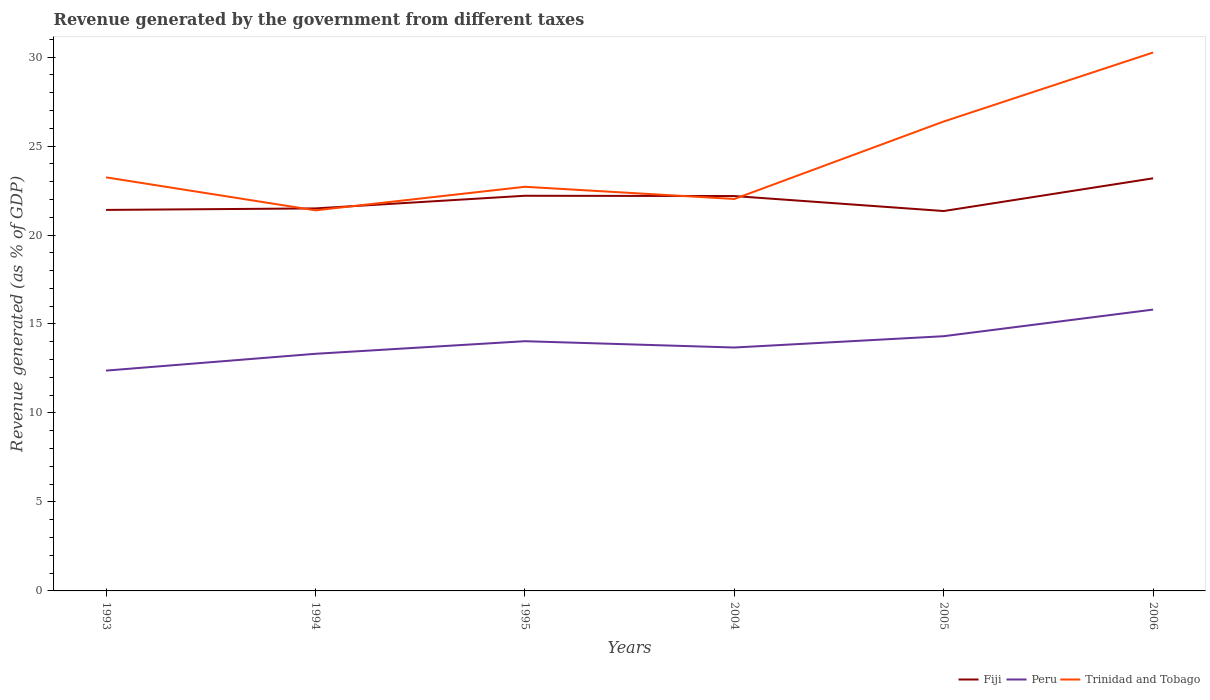Is the number of lines equal to the number of legend labels?
Your answer should be compact. Yes. Across all years, what is the maximum revenue generated by the government in Peru?
Ensure brevity in your answer.  12.38. In which year was the revenue generated by the government in Fiji maximum?
Offer a very short reply. 2005. What is the total revenue generated by the government in Trinidad and Tobago in the graph?
Your answer should be very brief. 0.69. What is the difference between the highest and the second highest revenue generated by the government in Peru?
Your answer should be compact. 3.43. What is the difference between the highest and the lowest revenue generated by the government in Peru?
Make the answer very short. 3. Is the revenue generated by the government in Peru strictly greater than the revenue generated by the government in Trinidad and Tobago over the years?
Your answer should be compact. Yes. How many lines are there?
Ensure brevity in your answer.  3. What is the difference between two consecutive major ticks on the Y-axis?
Make the answer very short. 5. Are the values on the major ticks of Y-axis written in scientific E-notation?
Your response must be concise. No. Does the graph contain grids?
Keep it short and to the point. No. How many legend labels are there?
Offer a very short reply. 3. What is the title of the graph?
Make the answer very short. Revenue generated by the government from different taxes. Does "Middle East & North Africa (developing only)" appear as one of the legend labels in the graph?
Make the answer very short. No. What is the label or title of the X-axis?
Keep it short and to the point. Years. What is the label or title of the Y-axis?
Offer a terse response. Revenue generated (as % of GDP). What is the Revenue generated (as % of GDP) in Fiji in 1993?
Give a very brief answer. 21.41. What is the Revenue generated (as % of GDP) in Peru in 1993?
Offer a terse response. 12.38. What is the Revenue generated (as % of GDP) in Trinidad and Tobago in 1993?
Keep it short and to the point. 23.24. What is the Revenue generated (as % of GDP) in Fiji in 1994?
Keep it short and to the point. 21.5. What is the Revenue generated (as % of GDP) in Peru in 1994?
Your answer should be compact. 13.33. What is the Revenue generated (as % of GDP) in Trinidad and Tobago in 1994?
Make the answer very short. 21.39. What is the Revenue generated (as % of GDP) of Fiji in 1995?
Your answer should be compact. 22.21. What is the Revenue generated (as % of GDP) in Peru in 1995?
Provide a short and direct response. 14.03. What is the Revenue generated (as % of GDP) in Trinidad and Tobago in 1995?
Provide a succinct answer. 22.71. What is the Revenue generated (as % of GDP) in Fiji in 2004?
Your response must be concise. 22.19. What is the Revenue generated (as % of GDP) in Peru in 2004?
Make the answer very short. 13.68. What is the Revenue generated (as % of GDP) in Trinidad and Tobago in 2004?
Make the answer very short. 22.03. What is the Revenue generated (as % of GDP) in Fiji in 2005?
Your answer should be very brief. 21.35. What is the Revenue generated (as % of GDP) in Peru in 2005?
Give a very brief answer. 14.31. What is the Revenue generated (as % of GDP) in Trinidad and Tobago in 2005?
Give a very brief answer. 26.38. What is the Revenue generated (as % of GDP) in Fiji in 2006?
Ensure brevity in your answer.  23.19. What is the Revenue generated (as % of GDP) of Peru in 2006?
Keep it short and to the point. 15.81. What is the Revenue generated (as % of GDP) of Trinidad and Tobago in 2006?
Offer a terse response. 30.26. Across all years, what is the maximum Revenue generated (as % of GDP) of Fiji?
Your answer should be compact. 23.19. Across all years, what is the maximum Revenue generated (as % of GDP) in Peru?
Ensure brevity in your answer.  15.81. Across all years, what is the maximum Revenue generated (as % of GDP) of Trinidad and Tobago?
Your answer should be very brief. 30.26. Across all years, what is the minimum Revenue generated (as % of GDP) of Fiji?
Offer a very short reply. 21.35. Across all years, what is the minimum Revenue generated (as % of GDP) of Peru?
Offer a very short reply. 12.38. Across all years, what is the minimum Revenue generated (as % of GDP) of Trinidad and Tobago?
Your answer should be very brief. 21.39. What is the total Revenue generated (as % of GDP) of Fiji in the graph?
Your answer should be very brief. 131.84. What is the total Revenue generated (as % of GDP) of Peru in the graph?
Your answer should be compact. 83.54. What is the total Revenue generated (as % of GDP) in Trinidad and Tobago in the graph?
Your answer should be very brief. 146. What is the difference between the Revenue generated (as % of GDP) of Fiji in 1993 and that in 1994?
Give a very brief answer. -0.09. What is the difference between the Revenue generated (as % of GDP) in Peru in 1993 and that in 1994?
Provide a short and direct response. -0.94. What is the difference between the Revenue generated (as % of GDP) in Trinidad and Tobago in 1993 and that in 1994?
Offer a terse response. 1.85. What is the difference between the Revenue generated (as % of GDP) in Fiji in 1993 and that in 1995?
Ensure brevity in your answer.  -0.8. What is the difference between the Revenue generated (as % of GDP) in Peru in 1993 and that in 1995?
Your response must be concise. -1.65. What is the difference between the Revenue generated (as % of GDP) of Trinidad and Tobago in 1993 and that in 1995?
Your answer should be compact. 0.53. What is the difference between the Revenue generated (as % of GDP) in Fiji in 1993 and that in 2004?
Keep it short and to the point. -0.78. What is the difference between the Revenue generated (as % of GDP) in Peru in 1993 and that in 2004?
Make the answer very short. -1.3. What is the difference between the Revenue generated (as % of GDP) of Trinidad and Tobago in 1993 and that in 2004?
Your answer should be compact. 1.21. What is the difference between the Revenue generated (as % of GDP) of Fiji in 1993 and that in 2005?
Your answer should be compact. 0.06. What is the difference between the Revenue generated (as % of GDP) of Peru in 1993 and that in 2005?
Keep it short and to the point. -1.93. What is the difference between the Revenue generated (as % of GDP) of Trinidad and Tobago in 1993 and that in 2005?
Give a very brief answer. -3.14. What is the difference between the Revenue generated (as % of GDP) in Fiji in 1993 and that in 2006?
Ensure brevity in your answer.  -1.78. What is the difference between the Revenue generated (as % of GDP) in Peru in 1993 and that in 2006?
Your response must be concise. -3.43. What is the difference between the Revenue generated (as % of GDP) in Trinidad and Tobago in 1993 and that in 2006?
Make the answer very short. -7.02. What is the difference between the Revenue generated (as % of GDP) in Fiji in 1994 and that in 1995?
Offer a very short reply. -0.71. What is the difference between the Revenue generated (as % of GDP) in Peru in 1994 and that in 1995?
Offer a terse response. -0.71. What is the difference between the Revenue generated (as % of GDP) in Trinidad and Tobago in 1994 and that in 1995?
Offer a very short reply. -1.32. What is the difference between the Revenue generated (as % of GDP) of Fiji in 1994 and that in 2004?
Make the answer very short. -0.69. What is the difference between the Revenue generated (as % of GDP) in Peru in 1994 and that in 2004?
Ensure brevity in your answer.  -0.35. What is the difference between the Revenue generated (as % of GDP) of Trinidad and Tobago in 1994 and that in 2004?
Give a very brief answer. -0.64. What is the difference between the Revenue generated (as % of GDP) in Fiji in 1994 and that in 2005?
Your answer should be very brief. 0.15. What is the difference between the Revenue generated (as % of GDP) in Peru in 1994 and that in 2005?
Ensure brevity in your answer.  -0.99. What is the difference between the Revenue generated (as % of GDP) in Trinidad and Tobago in 1994 and that in 2005?
Your answer should be compact. -4.99. What is the difference between the Revenue generated (as % of GDP) in Fiji in 1994 and that in 2006?
Provide a succinct answer. -1.69. What is the difference between the Revenue generated (as % of GDP) of Peru in 1994 and that in 2006?
Ensure brevity in your answer.  -2.48. What is the difference between the Revenue generated (as % of GDP) in Trinidad and Tobago in 1994 and that in 2006?
Provide a succinct answer. -8.87. What is the difference between the Revenue generated (as % of GDP) of Fiji in 1995 and that in 2004?
Your answer should be compact. 0.02. What is the difference between the Revenue generated (as % of GDP) of Peru in 1995 and that in 2004?
Provide a short and direct response. 0.35. What is the difference between the Revenue generated (as % of GDP) of Trinidad and Tobago in 1995 and that in 2004?
Provide a succinct answer. 0.69. What is the difference between the Revenue generated (as % of GDP) of Fiji in 1995 and that in 2005?
Keep it short and to the point. 0.86. What is the difference between the Revenue generated (as % of GDP) of Peru in 1995 and that in 2005?
Your answer should be compact. -0.28. What is the difference between the Revenue generated (as % of GDP) in Trinidad and Tobago in 1995 and that in 2005?
Keep it short and to the point. -3.67. What is the difference between the Revenue generated (as % of GDP) of Fiji in 1995 and that in 2006?
Make the answer very short. -0.98. What is the difference between the Revenue generated (as % of GDP) in Peru in 1995 and that in 2006?
Your answer should be compact. -1.78. What is the difference between the Revenue generated (as % of GDP) in Trinidad and Tobago in 1995 and that in 2006?
Provide a succinct answer. -7.55. What is the difference between the Revenue generated (as % of GDP) in Fiji in 2004 and that in 2005?
Make the answer very short. 0.84. What is the difference between the Revenue generated (as % of GDP) of Peru in 2004 and that in 2005?
Your response must be concise. -0.64. What is the difference between the Revenue generated (as % of GDP) of Trinidad and Tobago in 2004 and that in 2005?
Your answer should be very brief. -4.35. What is the difference between the Revenue generated (as % of GDP) in Fiji in 2004 and that in 2006?
Offer a very short reply. -1. What is the difference between the Revenue generated (as % of GDP) of Peru in 2004 and that in 2006?
Your answer should be very brief. -2.13. What is the difference between the Revenue generated (as % of GDP) of Trinidad and Tobago in 2004 and that in 2006?
Give a very brief answer. -8.23. What is the difference between the Revenue generated (as % of GDP) in Fiji in 2005 and that in 2006?
Your response must be concise. -1.84. What is the difference between the Revenue generated (as % of GDP) in Peru in 2005 and that in 2006?
Keep it short and to the point. -1.5. What is the difference between the Revenue generated (as % of GDP) of Trinidad and Tobago in 2005 and that in 2006?
Offer a terse response. -3.88. What is the difference between the Revenue generated (as % of GDP) of Fiji in 1993 and the Revenue generated (as % of GDP) of Peru in 1994?
Your answer should be very brief. 8.09. What is the difference between the Revenue generated (as % of GDP) in Fiji in 1993 and the Revenue generated (as % of GDP) in Trinidad and Tobago in 1994?
Make the answer very short. 0.02. What is the difference between the Revenue generated (as % of GDP) of Peru in 1993 and the Revenue generated (as % of GDP) of Trinidad and Tobago in 1994?
Keep it short and to the point. -9.01. What is the difference between the Revenue generated (as % of GDP) in Fiji in 1993 and the Revenue generated (as % of GDP) in Peru in 1995?
Provide a short and direct response. 7.38. What is the difference between the Revenue generated (as % of GDP) of Fiji in 1993 and the Revenue generated (as % of GDP) of Trinidad and Tobago in 1995?
Ensure brevity in your answer.  -1.3. What is the difference between the Revenue generated (as % of GDP) of Peru in 1993 and the Revenue generated (as % of GDP) of Trinidad and Tobago in 1995?
Make the answer very short. -10.33. What is the difference between the Revenue generated (as % of GDP) of Fiji in 1993 and the Revenue generated (as % of GDP) of Peru in 2004?
Keep it short and to the point. 7.73. What is the difference between the Revenue generated (as % of GDP) in Fiji in 1993 and the Revenue generated (as % of GDP) in Trinidad and Tobago in 2004?
Ensure brevity in your answer.  -0.61. What is the difference between the Revenue generated (as % of GDP) in Peru in 1993 and the Revenue generated (as % of GDP) in Trinidad and Tobago in 2004?
Your response must be concise. -9.64. What is the difference between the Revenue generated (as % of GDP) in Fiji in 1993 and the Revenue generated (as % of GDP) in Peru in 2005?
Keep it short and to the point. 7.1. What is the difference between the Revenue generated (as % of GDP) in Fiji in 1993 and the Revenue generated (as % of GDP) in Trinidad and Tobago in 2005?
Ensure brevity in your answer.  -4.97. What is the difference between the Revenue generated (as % of GDP) in Peru in 1993 and the Revenue generated (as % of GDP) in Trinidad and Tobago in 2005?
Provide a short and direct response. -14. What is the difference between the Revenue generated (as % of GDP) of Fiji in 1993 and the Revenue generated (as % of GDP) of Peru in 2006?
Offer a very short reply. 5.6. What is the difference between the Revenue generated (as % of GDP) in Fiji in 1993 and the Revenue generated (as % of GDP) in Trinidad and Tobago in 2006?
Your response must be concise. -8.85. What is the difference between the Revenue generated (as % of GDP) in Peru in 1993 and the Revenue generated (as % of GDP) in Trinidad and Tobago in 2006?
Offer a terse response. -17.88. What is the difference between the Revenue generated (as % of GDP) of Fiji in 1994 and the Revenue generated (as % of GDP) of Peru in 1995?
Your answer should be compact. 7.46. What is the difference between the Revenue generated (as % of GDP) of Fiji in 1994 and the Revenue generated (as % of GDP) of Trinidad and Tobago in 1995?
Ensure brevity in your answer.  -1.22. What is the difference between the Revenue generated (as % of GDP) of Peru in 1994 and the Revenue generated (as % of GDP) of Trinidad and Tobago in 1995?
Your answer should be very brief. -9.39. What is the difference between the Revenue generated (as % of GDP) of Fiji in 1994 and the Revenue generated (as % of GDP) of Peru in 2004?
Your response must be concise. 7.82. What is the difference between the Revenue generated (as % of GDP) of Fiji in 1994 and the Revenue generated (as % of GDP) of Trinidad and Tobago in 2004?
Give a very brief answer. -0.53. What is the difference between the Revenue generated (as % of GDP) of Peru in 1994 and the Revenue generated (as % of GDP) of Trinidad and Tobago in 2004?
Your answer should be very brief. -8.7. What is the difference between the Revenue generated (as % of GDP) of Fiji in 1994 and the Revenue generated (as % of GDP) of Peru in 2005?
Give a very brief answer. 7.18. What is the difference between the Revenue generated (as % of GDP) in Fiji in 1994 and the Revenue generated (as % of GDP) in Trinidad and Tobago in 2005?
Ensure brevity in your answer.  -4.88. What is the difference between the Revenue generated (as % of GDP) in Peru in 1994 and the Revenue generated (as % of GDP) in Trinidad and Tobago in 2005?
Offer a terse response. -13.05. What is the difference between the Revenue generated (as % of GDP) in Fiji in 1994 and the Revenue generated (as % of GDP) in Peru in 2006?
Your answer should be compact. 5.69. What is the difference between the Revenue generated (as % of GDP) in Fiji in 1994 and the Revenue generated (as % of GDP) in Trinidad and Tobago in 2006?
Provide a short and direct response. -8.76. What is the difference between the Revenue generated (as % of GDP) in Peru in 1994 and the Revenue generated (as % of GDP) in Trinidad and Tobago in 2006?
Provide a short and direct response. -16.93. What is the difference between the Revenue generated (as % of GDP) in Fiji in 1995 and the Revenue generated (as % of GDP) in Peru in 2004?
Make the answer very short. 8.53. What is the difference between the Revenue generated (as % of GDP) of Fiji in 1995 and the Revenue generated (as % of GDP) of Trinidad and Tobago in 2004?
Provide a short and direct response. 0.18. What is the difference between the Revenue generated (as % of GDP) in Peru in 1995 and the Revenue generated (as % of GDP) in Trinidad and Tobago in 2004?
Provide a short and direct response. -7.99. What is the difference between the Revenue generated (as % of GDP) in Fiji in 1995 and the Revenue generated (as % of GDP) in Peru in 2005?
Give a very brief answer. 7.89. What is the difference between the Revenue generated (as % of GDP) in Fiji in 1995 and the Revenue generated (as % of GDP) in Trinidad and Tobago in 2005?
Make the answer very short. -4.17. What is the difference between the Revenue generated (as % of GDP) of Peru in 1995 and the Revenue generated (as % of GDP) of Trinidad and Tobago in 2005?
Give a very brief answer. -12.35. What is the difference between the Revenue generated (as % of GDP) of Fiji in 1995 and the Revenue generated (as % of GDP) of Peru in 2006?
Your response must be concise. 6.4. What is the difference between the Revenue generated (as % of GDP) in Fiji in 1995 and the Revenue generated (as % of GDP) in Trinidad and Tobago in 2006?
Your response must be concise. -8.05. What is the difference between the Revenue generated (as % of GDP) in Peru in 1995 and the Revenue generated (as % of GDP) in Trinidad and Tobago in 2006?
Ensure brevity in your answer.  -16.22. What is the difference between the Revenue generated (as % of GDP) in Fiji in 2004 and the Revenue generated (as % of GDP) in Peru in 2005?
Your response must be concise. 7.88. What is the difference between the Revenue generated (as % of GDP) of Fiji in 2004 and the Revenue generated (as % of GDP) of Trinidad and Tobago in 2005?
Keep it short and to the point. -4.19. What is the difference between the Revenue generated (as % of GDP) of Peru in 2004 and the Revenue generated (as % of GDP) of Trinidad and Tobago in 2005?
Offer a terse response. -12.7. What is the difference between the Revenue generated (as % of GDP) of Fiji in 2004 and the Revenue generated (as % of GDP) of Peru in 2006?
Provide a succinct answer. 6.38. What is the difference between the Revenue generated (as % of GDP) of Fiji in 2004 and the Revenue generated (as % of GDP) of Trinidad and Tobago in 2006?
Make the answer very short. -8.07. What is the difference between the Revenue generated (as % of GDP) of Peru in 2004 and the Revenue generated (as % of GDP) of Trinidad and Tobago in 2006?
Keep it short and to the point. -16.58. What is the difference between the Revenue generated (as % of GDP) of Fiji in 2005 and the Revenue generated (as % of GDP) of Peru in 2006?
Ensure brevity in your answer.  5.54. What is the difference between the Revenue generated (as % of GDP) in Fiji in 2005 and the Revenue generated (as % of GDP) in Trinidad and Tobago in 2006?
Offer a terse response. -8.91. What is the difference between the Revenue generated (as % of GDP) of Peru in 2005 and the Revenue generated (as % of GDP) of Trinidad and Tobago in 2006?
Your answer should be very brief. -15.94. What is the average Revenue generated (as % of GDP) in Fiji per year?
Make the answer very short. 21.97. What is the average Revenue generated (as % of GDP) in Peru per year?
Offer a terse response. 13.92. What is the average Revenue generated (as % of GDP) of Trinidad and Tobago per year?
Your answer should be very brief. 24.33. In the year 1993, what is the difference between the Revenue generated (as % of GDP) of Fiji and Revenue generated (as % of GDP) of Peru?
Give a very brief answer. 9.03. In the year 1993, what is the difference between the Revenue generated (as % of GDP) in Fiji and Revenue generated (as % of GDP) in Trinidad and Tobago?
Give a very brief answer. -1.83. In the year 1993, what is the difference between the Revenue generated (as % of GDP) in Peru and Revenue generated (as % of GDP) in Trinidad and Tobago?
Give a very brief answer. -10.86. In the year 1994, what is the difference between the Revenue generated (as % of GDP) of Fiji and Revenue generated (as % of GDP) of Peru?
Offer a terse response. 8.17. In the year 1994, what is the difference between the Revenue generated (as % of GDP) in Fiji and Revenue generated (as % of GDP) in Trinidad and Tobago?
Ensure brevity in your answer.  0.11. In the year 1994, what is the difference between the Revenue generated (as % of GDP) of Peru and Revenue generated (as % of GDP) of Trinidad and Tobago?
Your response must be concise. -8.06. In the year 1995, what is the difference between the Revenue generated (as % of GDP) of Fiji and Revenue generated (as % of GDP) of Peru?
Ensure brevity in your answer.  8.17. In the year 1995, what is the difference between the Revenue generated (as % of GDP) in Fiji and Revenue generated (as % of GDP) in Trinidad and Tobago?
Make the answer very short. -0.5. In the year 1995, what is the difference between the Revenue generated (as % of GDP) of Peru and Revenue generated (as % of GDP) of Trinidad and Tobago?
Provide a short and direct response. -8.68. In the year 2004, what is the difference between the Revenue generated (as % of GDP) of Fiji and Revenue generated (as % of GDP) of Peru?
Make the answer very short. 8.51. In the year 2004, what is the difference between the Revenue generated (as % of GDP) of Fiji and Revenue generated (as % of GDP) of Trinidad and Tobago?
Provide a short and direct response. 0.16. In the year 2004, what is the difference between the Revenue generated (as % of GDP) in Peru and Revenue generated (as % of GDP) in Trinidad and Tobago?
Give a very brief answer. -8.35. In the year 2005, what is the difference between the Revenue generated (as % of GDP) in Fiji and Revenue generated (as % of GDP) in Peru?
Ensure brevity in your answer.  7.03. In the year 2005, what is the difference between the Revenue generated (as % of GDP) of Fiji and Revenue generated (as % of GDP) of Trinidad and Tobago?
Keep it short and to the point. -5.03. In the year 2005, what is the difference between the Revenue generated (as % of GDP) of Peru and Revenue generated (as % of GDP) of Trinidad and Tobago?
Your answer should be very brief. -12.06. In the year 2006, what is the difference between the Revenue generated (as % of GDP) in Fiji and Revenue generated (as % of GDP) in Peru?
Provide a succinct answer. 7.38. In the year 2006, what is the difference between the Revenue generated (as % of GDP) of Fiji and Revenue generated (as % of GDP) of Trinidad and Tobago?
Provide a short and direct response. -7.07. In the year 2006, what is the difference between the Revenue generated (as % of GDP) of Peru and Revenue generated (as % of GDP) of Trinidad and Tobago?
Your answer should be very brief. -14.45. What is the ratio of the Revenue generated (as % of GDP) of Fiji in 1993 to that in 1994?
Your answer should be very brief. 1. What is the ratio of the Revenue generated (as % of GDP) in Peru in 1993 to that in 1994?
Provide a short and direct response. 0.93. What is the ratio of the Revenue generated (as % of GDP) in Trinidad and Tobago in 1993 to that in 1994?
Offer a very short reply. 1.09. What is the ratio of the Revenue generated (as % of GDP) in Fiji in 1993 to that in 1995?
Ensure brevity in your answer.  0.96. What is the ratio of the Revenue generated (as % of GDP) in Peru in 1993 to that in 1995?
Your answer should be compact. 0.88. What is the ratio of the Revenue generated (as % of GDP) of Trinidad and Tobago in 1993 to that in 1995?
Your answer should be compact. 1.02. What is the ratio of the Revenue generated (as % of GDP) in Fiji in 1993 to that in 2004?
Your answer should be compact. 0.96. What is the ratio of the Revenue generated (as % of GDP) of Peru in 1993 to that in 2004?
Your answer should be very brief. 0.91. What is the ratio of the Revenue generated (as % of GDP) of Trinidad and Tobago in 1993 to that in 2004?
Your answer should be compact. 1.06. What is the ratio of the Revenue generated (as % of GDP) in Fiji in 1993 to that in 2005?
Offer a very short reply. 1. What is the ratio of the Revenue generated (as % of GDP) in Peru in 1993 to that in 2005?
Provide a succinct answer. 0.86. What is the ratio of the Revenue generated (as % of GDP) of Trinidad and Tobago in 1993 to that in 2005?
Make the answer very short. 0.88. What is the ratio of the Revenue generated (as % of GDP) in Fiji in 1993 to that in 2006?
Provide a succinct answer. 0.92. What is the ratio of the Revenue generated (as % of GDP) in Peru in 1993 to that in 2006?
Give a very brief answer. 0.78. What is the ratio of the Revenue generated (as % of GDP) in Trinidad and Tobago in 1993 to that in 2006?
Your answer should be very brief. 0.77. What is the ratio of the Revenue generated (as % of GDP) of Fiji in 1994 to that in 1995?
Give a very brief answer. 0.97. What is the ratio of the Revenue generated (as % of GDP) of Peru in 1994 to that in 1995?
Offer a terse response. 0.95. What is the ratio of the Revenue generated (as % of GDP) in Trinidad and Tobago in 1994 to that in 1995?
Keep it short and to the point. 0.94. What is the ratio of the Revenue generated (as % of GDP) in Fiji in 1994 to that in 2004?
Ensure brevity in your answer.  0.97. What is the ratio of the Revenue generated (as % of GDP) in Peru in 1994 to that in 2004?
Keep it short and to the point. 0.97. What is the ratio of the Revenue generated (as % of GDP) of Trinidad and Tobago in 1994 to that in 2004?
Your answer should be very brief. 0.97. What is the ratio of the Revenue generated (as % of GDP) of Fiji in 1994 to that in 2005?
Make the answer very short. 1.01. What is the ratio of the Revenue generated (as % of GDP) in Peru in 1994 to that in 2005?
Give a very brief answer. 0.93. What is the ratio of the Revenue generated (as % of GDP) of Trinidad and Tobago in 1994 to that in 2005?
Keep it short and to the point. 0.81. What is the ratio of the Revenue generated (as % of GDP) of Fiji in 1994 to that in 2006?
Provide a succinct answer. 0.93. What is the ratio of the Revenue generated (as % of GDP) in Peru in 1994 to that in 2006?
Make the answer very short. 0.84. What is the ratio of the Revenue generated (as % of GDP) of Trinidad and Tobago in 1994 to that in 2006?
Your answer should be very brief. 0.71. What is the ratio of the Revenue generated (as % of GDP) of Fiji in 1995 to that in 2004?
Offer a terse response. 1. What is the ratio of the Revenue generated (as % of GDP) in Peru in 1995 to that in 2004?
Provide a succinct answer. 1.03. What is the ratio of the Revenue generated (as % of GDP) in Trinidad and Tobago in 1995 to that in 2004?
Keep it short and to the point. 1.03. What is the ratio of the Revenue generated (as % of GDP) in Fiji in 1995 to that in 2005?
Provide a short and direct response. 1.04. What is the ratio of the Revenue generated (as % of GDP) in Peru in 1995 to that in 2005?
Your answer should be compact. 0.98. What is the ratio of the Revenue generated (as % of GDP) of Trinidad and Tobago in 1995 to that in 2005?
Provide a succinct answer. 0.86. What is the ratio of the Revenue generated (as % of GDP) of Fiji in 1995 to that in 2006?
Provide a short and direct response. 0.96. What is the ratio of the Revenue generated (as % of GDP) in Peru in 1995 to that in 2006?
Give a very brief answer. 0.89. What is the ratio of the Revenue generated (as % of GDP) of Trinidad and Tobago in 1995 to that in 2006?
Provide a short and direct response. 0.75. What is the ratio of the Revenue generated (as % of GDP) of Fiji in 2004 to that in 2005?
Give a very brief answer. 1.04. What is the ratio of the Revenue generated (as % of GDP) of Peru in 2004 to that in 2005?
Make the answer very short. 0.96. What is the ratio of the Revenue generated (as % of GDP) in Trinidad and Tobago in 2004 to that in 2005?
Provide a succinct answer. 0.83. What is the ratio of the Revenue generated (as % of GDP) of Fiji in 2004 to that in 2006?
Provide a short and direct response. 0.96. What is the ratio of the Revenue generated (as % of GDP) of Peru in 2004 to that in 2006?
Give a very brief answer. 0.87. What is the ratio of the Revenue generated (as % of GDP) in Trinidad and Tobago in 2004 to that in 2006?
Your response must be concise. 0.73. What is the ratio of the Revenue generated (as % of GDP) of Fiji in 2005 to that in 2006?
Ensure brevity in your answer.  0.92. What is the ratio of the Revenue generated (as % of GDP) in Peru in 2005 to that in 2006?
Offer a terse response. 0.91. What is the ratio of the Revenue generated (as % of GDP) of Trinidad and Tobago in 2005 to that in 2006?
Make the answer very short. 0.87. What is the difference between the highest and the second highest Revenue generated (as % of GDP) of Fiji?
Give a very brief answer. 0.98. What is the difference between the highest and the second highest Revenue generated (as % of GDP) in Peru?
Make the answer very short. 1.5. What is the difference between the highest and the second highest Revenue generated (as % of GDP) of Trinidad and Tobago?
Your answer should be compact. 3.88. What is the difference between the highest and the lowest Revenue generated (as % of GDP) in Fiji?
Make the answer very short. 1.84. What is the difference between the highest and the lowest Revenue generated (as % of GDP) of Peru?
Make the answer very short. 3.43. What is the difference between the highest and the lowest Revenue generated (as % of GDP) in Trinidad and Tobago?
Your response must be concise. 8.87. 